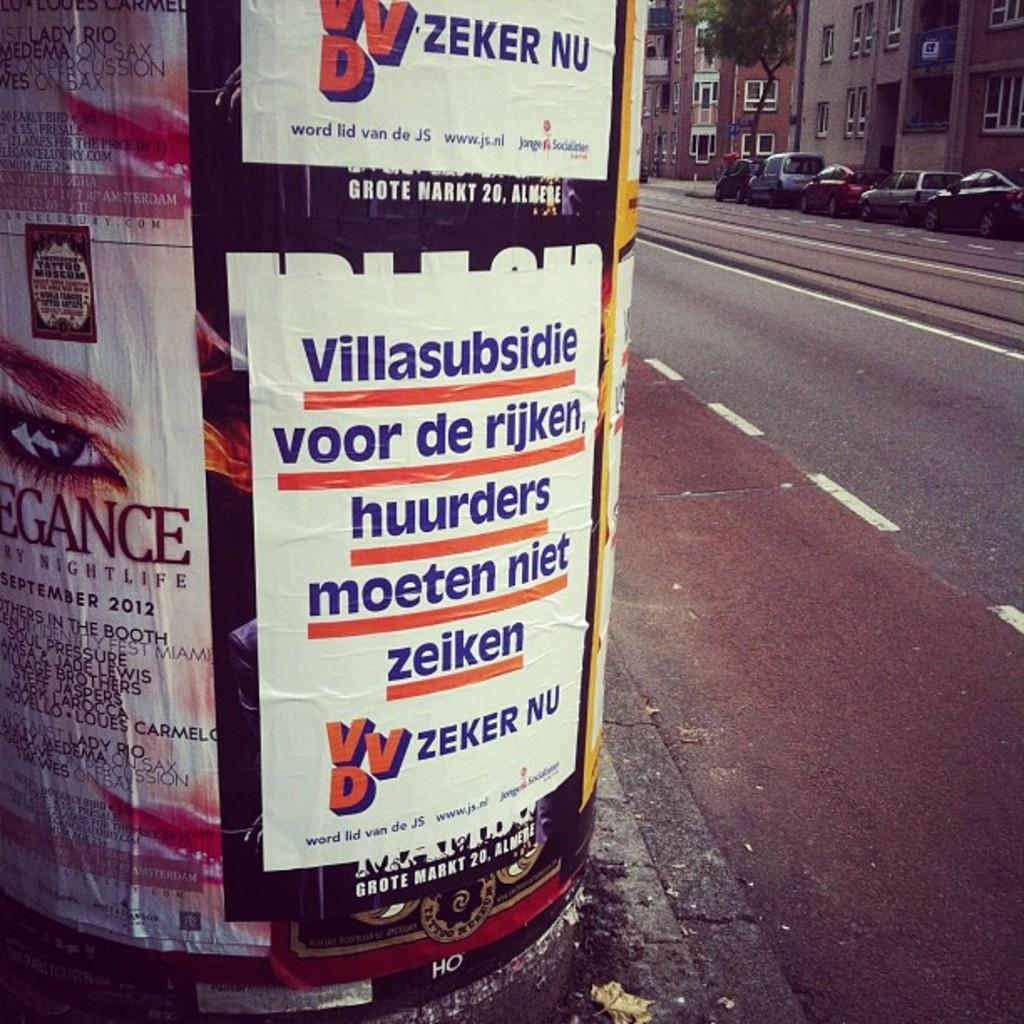<image>
Describe the image concisely. Sign on a pole which says "Villasubsidie" as the first word. 